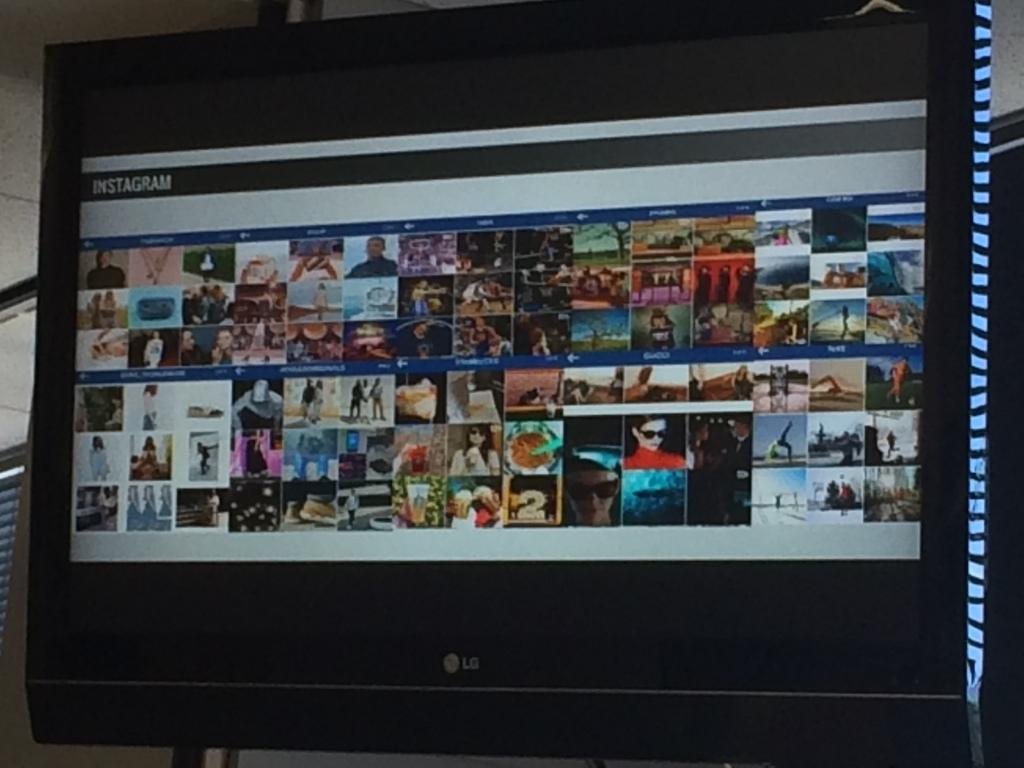<image>
Describe the image concisely. A large LG screen displaying an Instagram page 